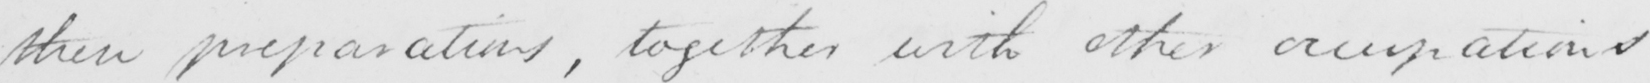Can you tell me what this handwritten text says? these preparations , together with other occupations 